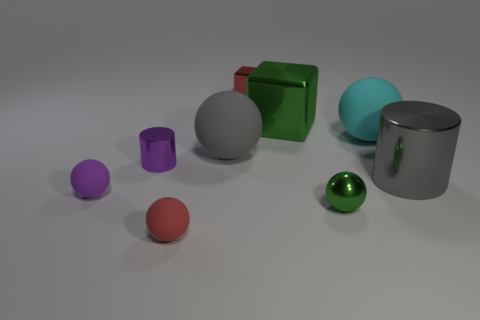What is the size of the sphere that is the same color as the big cylinder?
Keep it short and to the point. Large. What number of objects are either large shiny things that are right of the big cyan ball or small metallic things to the right of the tiny red matte sphere?
Provide a succinct answer. 3. Is there any other thing that is the same color as the small metallic ball?
Keep it short and to the point. Yes. There is a metallic object that is on the right side of the matte sphere that is to the right of the metallic thing in front of the big gray cylinder; what is its color?
Your response must be concise. Gray. There is a green metallic object that is behind the purple thing that is in front of the tiny purple shiny cylinder; what size is it?
Make the answer very short. Large. There is a small thing that is both in front of the tiny metallic cylinder and on the left side of the small red sphere; what is its material?
Your response must be concise. Rubber. Do the metallic sphere and the gray object that is left of the tiny metal ball have the same size?
Your answer should be compact. No. Is there a small blue cylinder?
Provide a short and direct response. No. What is the material of the small red thing that is the same shape as the small purple rubber thing?
Provide a succinct answer. Rubber. There is a red object that is behind the tiny purple thing behind the shiny cylinder that is to the right of the tiny green metal sphere; how big is it?
Provide a short and direct response. Small. 